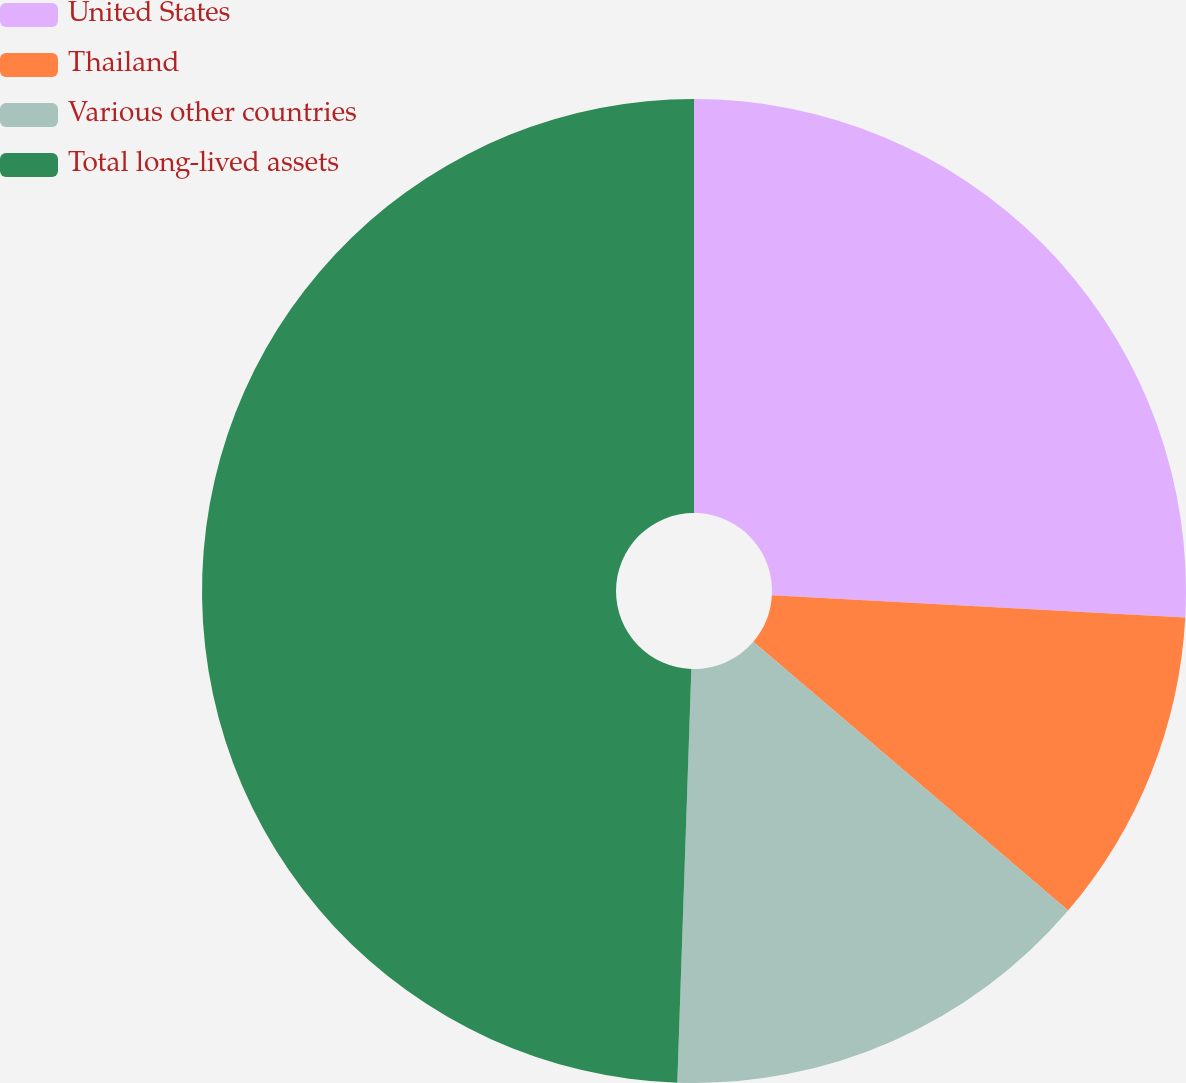<chart> <loc_0><loc_0><loc_500><loc_500><pie_chart><fcel>United States<fcel>Thailand<fcel>Various other countries<fcel>Total long-lived assets<nl><fcel>25.86%<fcel>10.39%<fcel>14.29%<fcel>49.46%<nl></chart> 